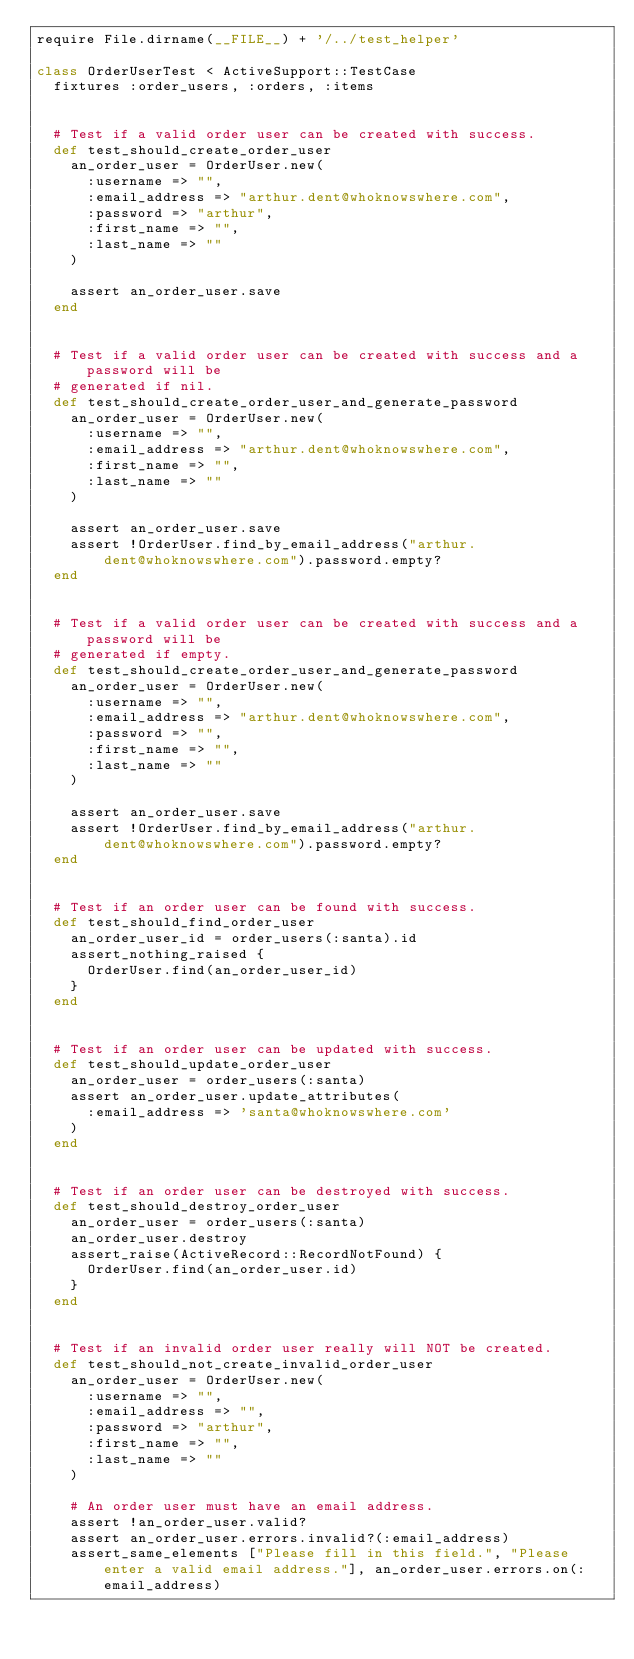Convert code to text. <code><loc_0><loc_0><loc_500><loc_500><_Ruby_>require File.dirname(__FILE__) + '/../test_helper'

class OrderUserTest < ActiveSupport::TestCase
  fixtures :order_users, :orders, :items


  # Test if a valid order user can be created with success.
  def test_should_create_order_user
    an_order_user = OrderUser.new(
      :username => "",
      :email_address => "arthur.dent@whoknowswhere.com",
      :password => "arthur",
      :first_name => "",
      :last_name => ""
    )
  
    assert an_order_user.save
  end


  # Test if a valid order user can be created with success and a password will be
  # generated if nil.
  def test_should_create_order_user_and_generate_password
    an_order_user = OrderUser.new(
      :username => "",
      :email_address => "arthur.dent@whoknowswhere.com",
      :first_name => "",
      :last_name => ""
    )
  
    assert an_order_user.save
    assert !OrderUser.find_by_email_address("arthur.dent@whoknowswhere.com").password.empty?
  end
  
  
  # Test if a valid order user can be created with success and a password will be
  # generated if empty.
  def test_should_create_order_user_and_generate_password
    an_order_user = OrderUser.new(
      :username => "",
      :email_address => "arthur.dent@whoknowswhere.com",
      :password => "",
      :first_name => "",
      :last_name => ""
    )
  
    assert an_order_user.save
    assert !OrderUser.find_by_email_address("arthur.dent@whoknowswhere.com").password.empty?
  end

  
  # Test if an order user can be found with success.
  def test_should_find_order_user
    an_order_user_id = order_users(:santa).id
    assert_nothing_raised {
      OrderUser.find(an_order_user_id)
    }
  end


  # Test if an order user can be updated with success.
  def test_should_update_order_user
    an_order_user = order_users(:santa)
    assert an_order_user.update_attributes(
      :email_address => 'santa@whoknowswhere.com'
    )
  end


  # Test if an order user can be destroyed with success.
  def test_should_destroy_order_user
    an_order_user = order_users(:santa)
    an_order_user.destroy
    assert_raise(ActiveRecord::RecordNotFound) {
      OrderUser.find(an_order_user.id)
    }
  end


  # Test if an invalid order user really will NOT be created.
  def test_should_not_create_invalid_order_user
    an_order_user = OrderUser.new(
      :username => "",
      :email_address => "",
      :password => "arthur",
      :first_name => "",
      :last_name => ""
    )

    # An order user must have an email address.
    assert !an_order_user.valid?
    assert an_order_user.errors.invalid?(:email_address)
    assert_same_elements ["Please fill in this field.", "Please enter a valid email address."], an_order_user.errors.on(:email_address)
</code> 